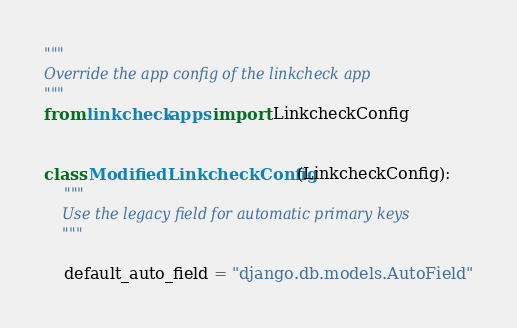Convert code to text. <code><loc_0><loc_0><loc_500><loc_500><_Python_>"""
Override the app config of the linkcheck app
"""
from linkcheck.apps import LinkcheckConfig


class ModifiedLinkcheckConfig(LinkcheckConfig):
    """
    Use the legacy field for automatic primary keys
    """

    default_auto_field = "django.db.models.AutoField"
</code> 